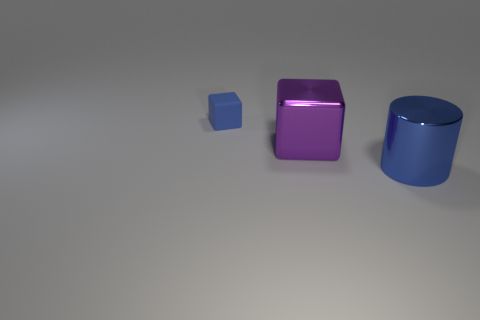There is a cube in front of the tiny cube; how big is it?
Provide a succinct answer. Large. What size is the metal cylinder that is the same color as the tiny cube?
Offer a terse response. Large. Is there a large blue thing made of the same material as the big blue cylinder?
Make the answer very short. No. Is the tiny thing made of the same material as the large blue cylinder?
Your answer should be very brief. No. There is a metal object that is the same size as the shiny cylinder; what is its color?
Offer a very short reply. Purple. What number of other objects are the same shape as the tiny matte thing?
Give a very brief answer. 1. There is a cylinder; does it have the same size as the blue object that is to the left of the big blue object?
Give a very brief answer. No. What number of things are big objects or blue metallic cylinders?
Keep it short and to the point. 2. How many other things are the same size as the metal cylinder?
Ensure brevity in your answer.  1. There is a metal block; does it have the same color as the cube that is behind the purple object?
Ensure brevity in your answer.  No. 